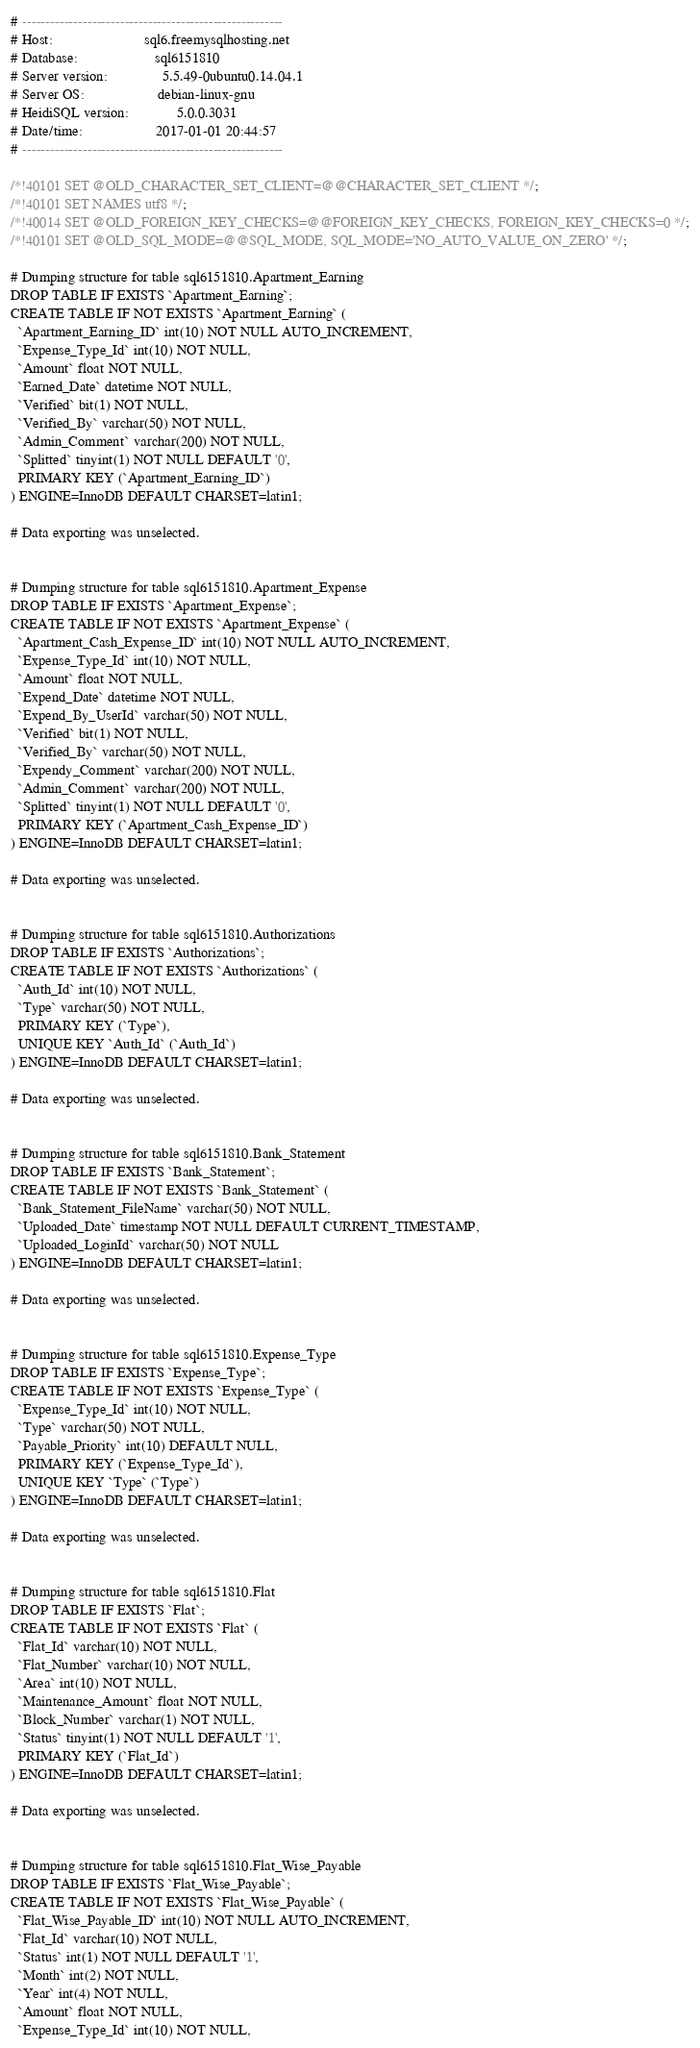Convert code to text. <code><loc_0><loc_0><loc_500><loc_500><_SQL_># --------------------------------------------------------
# Host:                         sql6.freemysqlhosting.net
# Database:                     sql6151810
# Server version:               5.5.49-0ubuntu0.14.04.1
# Server OS:                    debian-linux-gnu
# HeidiSQL version:             5.0.0.3031
# Date/time:                    2017-01-01 20:44:57
# --------------------------------------------------------

/*!40101 SET @OLD_CHARACTER_SET_CLIENT=@@CHARACTER_SET_CLIENT */;
/*!40101 SET NAMES utf8 */;
/*!40014 SET @OLD_FOREIGN_KEY_CHECKS=@@FOREIGN_KEY_CHECKS, FOREIGN_KEY_CHECKS=0 */;
/*!40101 SET @OLD_SQL_MODE=@@SQL_MODE, SQL_MODE='NO_AUTO_VALUE_ON_ZERO' */;

# Dumping structure for table sql6151810.Apartment_Earning
DROP TABLE IF EXISTS `Apartment_Earning`;
CREATE TABLE IF NOT EXISTS `Apartment_Earning` (
  `Apartment_Earning_ID` int(10) NOT NULL AUTO_INCREMENT,
  `Expense_Type_Id` int(10) NOT NULL,
  `Amount` float NOT NULL,
  `Earned_Date` datetime NOT NULL,
  `Verified` bit(1) NOT NULL,
  `Verified_By` varchar(50) NOT NULL,
  `Admin_Comment` varchar(200) NOT NULL,
  `Splitted` tinyint(1) NOT NULL DEFAULT '0',
  PRIMARY KEY (`Apartment_Earning_ID`)
) ENGINE=InnoDB DEFAULT CHARSET=latin1;

# Data exporting was unselected.


# Dumping structure for table sql6151810.Apartment_Expense
DROP TABLE IF EXISTS `Apartment_Expense`;
CREATE TABLE IF NOT EXISTS `Apartment_Expense` (
  `Apartment_Cash_Expense_ID` int(10) NOT NULL AUTO_INCREMENT,
  `Expense_Type_Id` int(10) NOT NULL,
  `Amount` float NOT NULL,
  `Expend_Date` datetime NOT NULL,
  `Expend_By_UserId` varchar(50) NOT NULL,
  `Verified` bit(1) NOT NULL,
  `Verified_By` varchar(50) NOT NULL,
  `Expendy_Comment` varchar(200) NOT NULL,
  `Admin_Comment` varchar(200) NOT NULL,
  `Splitted` tinyint(1) NOT NULL DEFAULT '0',
  PRIMARY KEY (`Apartment_Cash_Expense_ID`)
) ENGINE=InnoDB DEFAULT CHARSET=latin1;

# Data exporting was unselected.


# Dumping structure for table sql6151810.Authorizations
DROP TABLE IF EXISTS `Authorizations`;
CREATE TABLE IF NOT EXISTS `Authorizations` (
  `Auth_Id` int(10) NOT NULL,
  `Type` varchar(50) NOT NULL,
  PRIMARY KEY (`Type`),
  UNIQUE KEY `Auth_Id` (`Auth_Id`)
) ENGINE=InnoDB DEFAULT CHARSET=latin1;

# Data exporting was unselected.


# Dumping structure for table sql6151810.Bank_Statement
DROP TABLE IF EXISTS `Bank_Statement`;
CREATE TABLE IF NOT EXISTS `Bank_Statement` (
  `Bank_Statement_FileName` varchar(50) NOT NULL,
  `Uploaded_Date` timestamp NOT NULL DEFAULT CURRENT_TIMESTAMP,
  `Uploaded_LoginId` varchar(50) NOT NULL
) ENGINE=InnoDB DEFAULT CHARSET=latin1;

# Data exporting was unselected.


# Dumping structure for table sql6151810.Expense_Type
DROP TABLE IF EXISTS `Expense_Type`;
CREATE TABLE IF NOT EXISTS `Expense_Type` (
  `Expense_Type_Id` int(10) NOT NULL,
  `Type` varchar(50) NOT NULL,
  `Payable_Priority` int(10) DEFAULT NULL,
  PRIMARY KEY (`Expense_Type_Id`),
  UNIQUE KEY `Type` (`Type`)
) ENGINE=InnoDB DEFAULT CHARSET=latin1;

# Data exporting was unselected.


# Dumping structure for table sql6151810.Flat
DROP TABLE IF EXISTS `Flat`;
CREATE TABLE IF NOT EXISTS `Flat` (
  `Flat_Id` varchar(10) NOT NULL,
  `Flat_Number` varchar(10) NOT NULL,
  `Area` int(10) NOT NULL,
  `Maintenance_Amount` float NOT NULL,
  `Block_Number` varchar(1) NOT NULL,
  `Status` tinyint(1) NOT NULL DEFAULT '1',
  PRIMARY KEY (`Flat_Id`)
) ENGINE=InnoDB DEFAULT CHARSET=latin1;

# Data exporting was unselected.


# Dumping structure for table sql6151810.Flat_Wise_Payable
DROP TABLE IF EXISTS `Flat_Wise_Payable`;
CREATE TABLE IF NOT EXISTS `Flat_Wise_Payable` (
  `Flat_Wise_Payable_ID` int(10) NOT NULL AUTO_INCREMENT,
  `Flat_Id` varchar(10) NOT NULL,
  `Status` int(1) NOT NULL DEFAULT '1',
  `Month` int(2) NOT NULL,
  `Year` int(4) NOT NULL,
  `Amount` float NOT NULL,
  `Expense_Type_Id` int(10) NOT NULL,</code> 